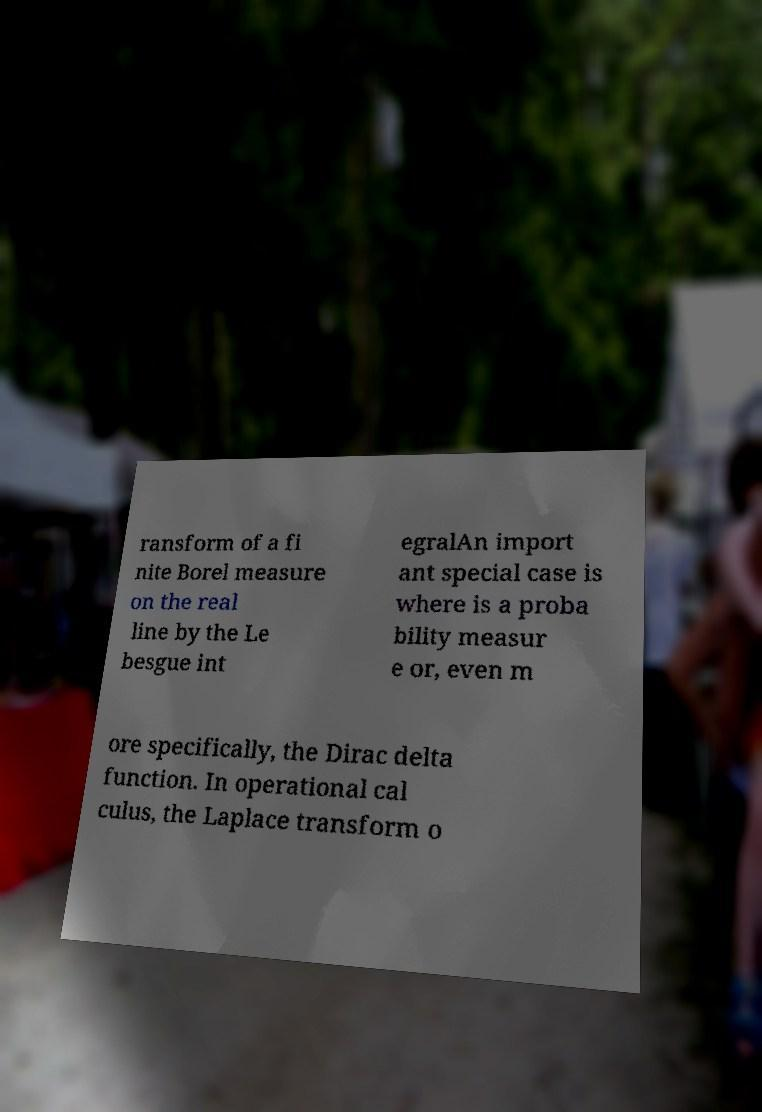For documentation purposes, I need the text within this image transcribed. Could you provide that? ransform of a fi nite Borel measure on the real line by the Le besgue int egralAn import ant special case is where is a proba bility measur e or, even m ore specifically, the Dirac delta function. In operational cal culus, the Laplace transform o 